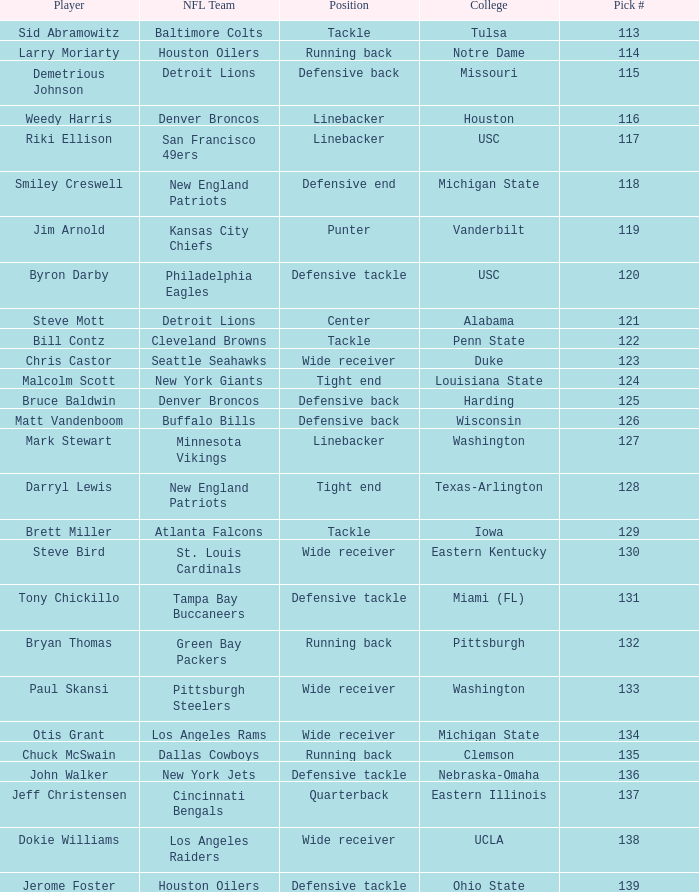What was bruce baldwin's pick #? 125.0. 